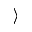<formula> <loc_0><loc_0><loc_500><loc_500>\rangle</formula> 